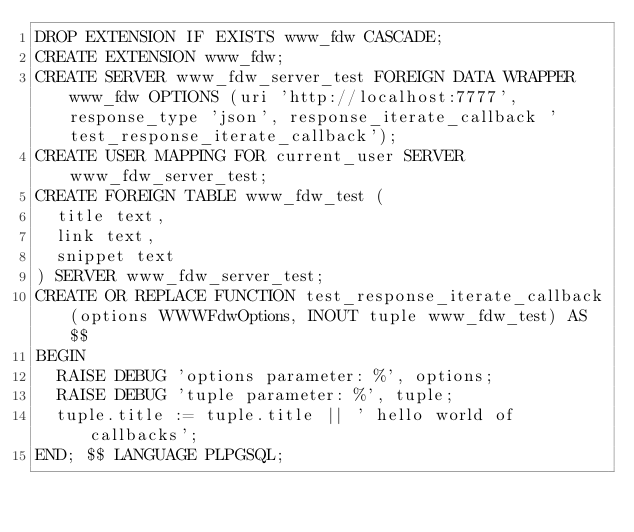Convert code to text. <code><loc_0><loc_0><loc_500><loc_500><_SQL_>DROP EXTENSION IF EXISTS www_fdw CASCADE;
CREATE EXTENSION www_fdw;
CREATE SERVER www_fdw_server_test FOREIGN DATA WRAPPER www_fdw OPTIONS (uri 'http://localhost:7777', response_type 'json', response_iterate_callback 'test_response_iterate_callback');
CREATE USER MAPPING FOR current_user SERVER www_fdw_server_test;
CREATE FOREIGN TABLE www_fdw_test (
	title text,                                                        
	link text,
	snippet text
) SERVER www_fdw_server_test;
CREATE OR REPLACE FUNCTION test_response_iterate_callback(options WWWFdwOptions, INOUT tuple www_fdw_test) AS $$
BEGIN
	RAISE DEBUG 'options parameter: %', options;
	RAISE DEBUG 'tuple parameter: %', tuple;
	tuple.title := tuple.title || ' hello world of callbacks';
END; $$ LANGUAGE PLPGSQL;</code> 